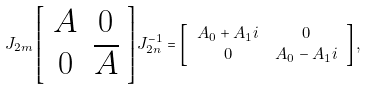<formula> <loc_0><loc_0><loc_500><loc_500>J _ { 2 m } \left [ \begin{array} { c c } A & 0 \\ 0 & \overline { A } \end{array} \right ] J _ { 2 n } ^ { - 1 } & = \left [ \begin{array} { c c } A _ { 0 } + A _ { 1 } i & 0 \\ 0 & A _ { 0 } - A _ { 1 } i \end{array} \right ] ,</formula> 